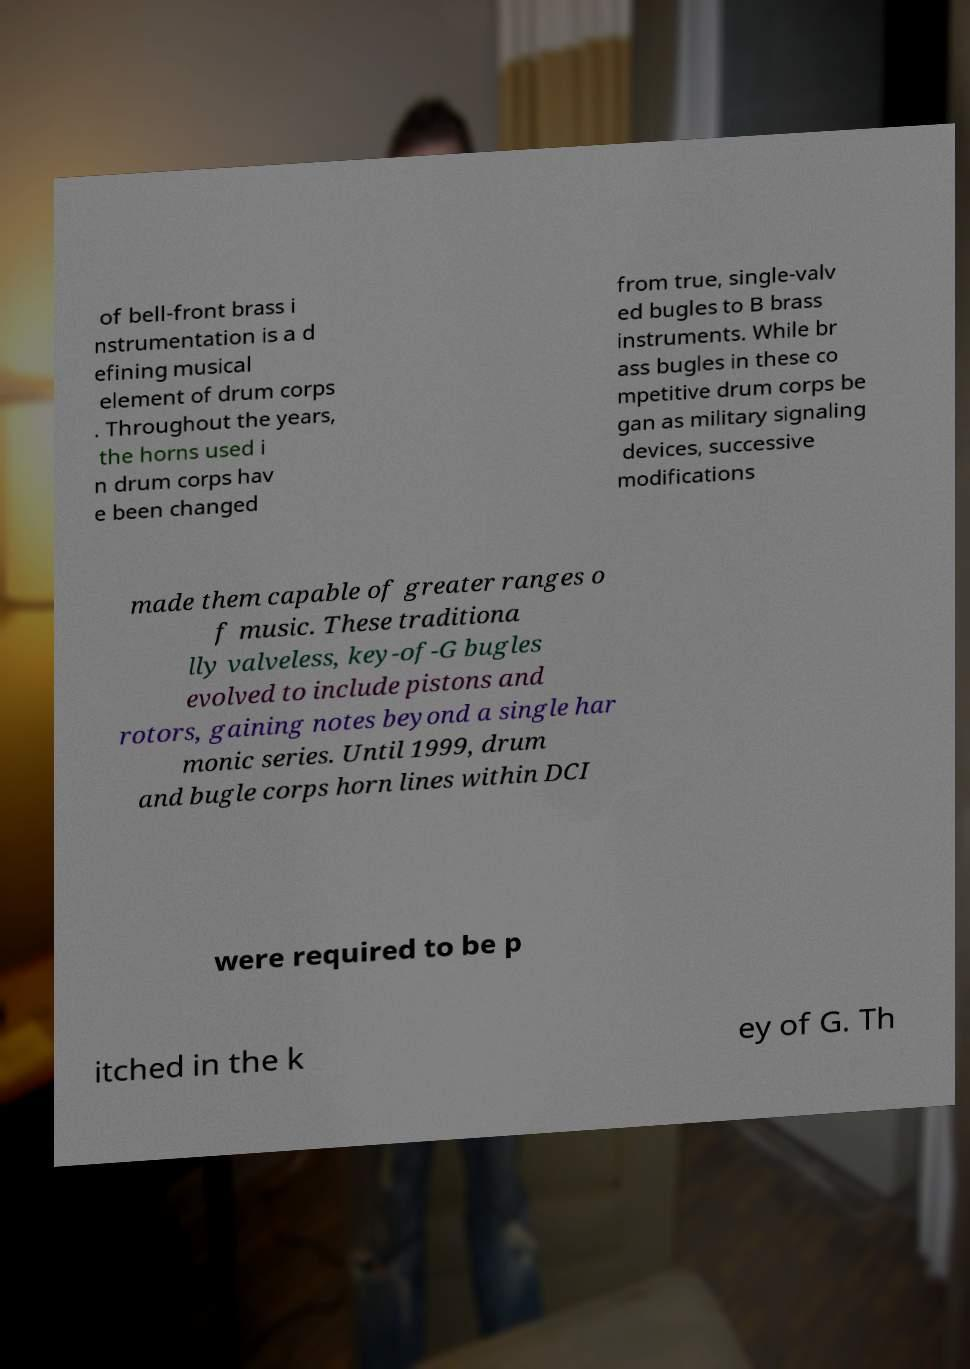Please identify and transcribe the text found in this image. of bell-front brass i nstrumentation is a d efining musical element of drum corps . Throughout the years, the horns used i n drum corps hav e been changed from true, single-valv ed bugles to B brass instruments. While br ass bugles in these co mpetitive drum corps be gan as military signaling devices, successive modifications made them capable of greater ranges o f music. These traditiona lly valveless, key-of-G bugles evolved to include pistons and rotors, gaining notes beyond a single har monic series. Until 1999, drum and bugle corps horn lines within DCI were required to be p itched in the k ey of G. Th 